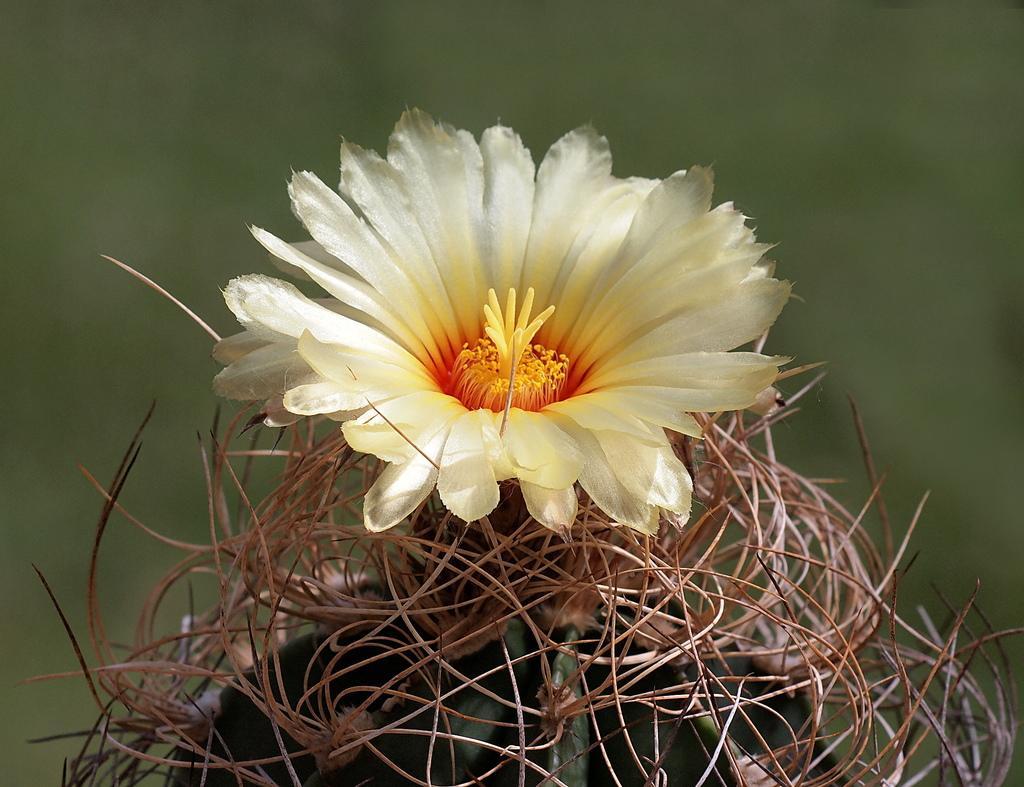Describe this image in one or two sentences. In this image I can see a flower which is cream, yellow and orange in color to a plant which is green and brown in color. I can see the blurry background which is green in color. 